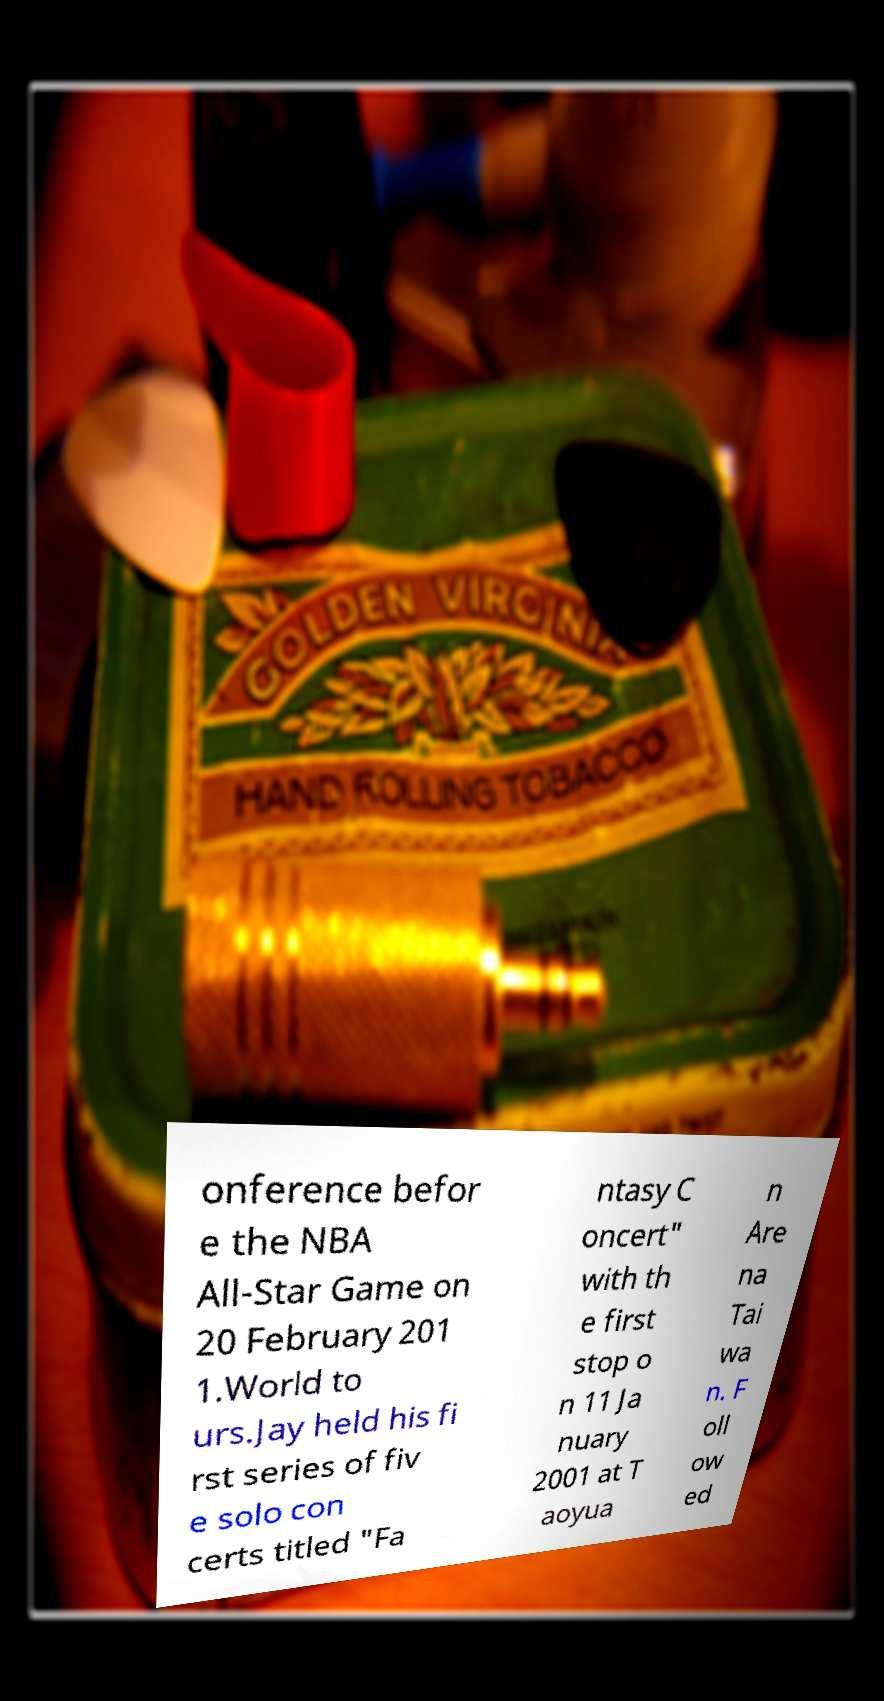Can you read and provide the text displayed in the image?This photo seems to have some interesting text. Can you extract and type it out for me? onference befor e the NBA All-Star Game on 20 February 201 1.World to urs.Jay held his fi rst series of fiv e solo con certs titled "Fa ntasy C oncert" with th e first stop o n 11 Ja nuary 2001 at T aoyua n Are na Tai wa n. F oll ow ed 